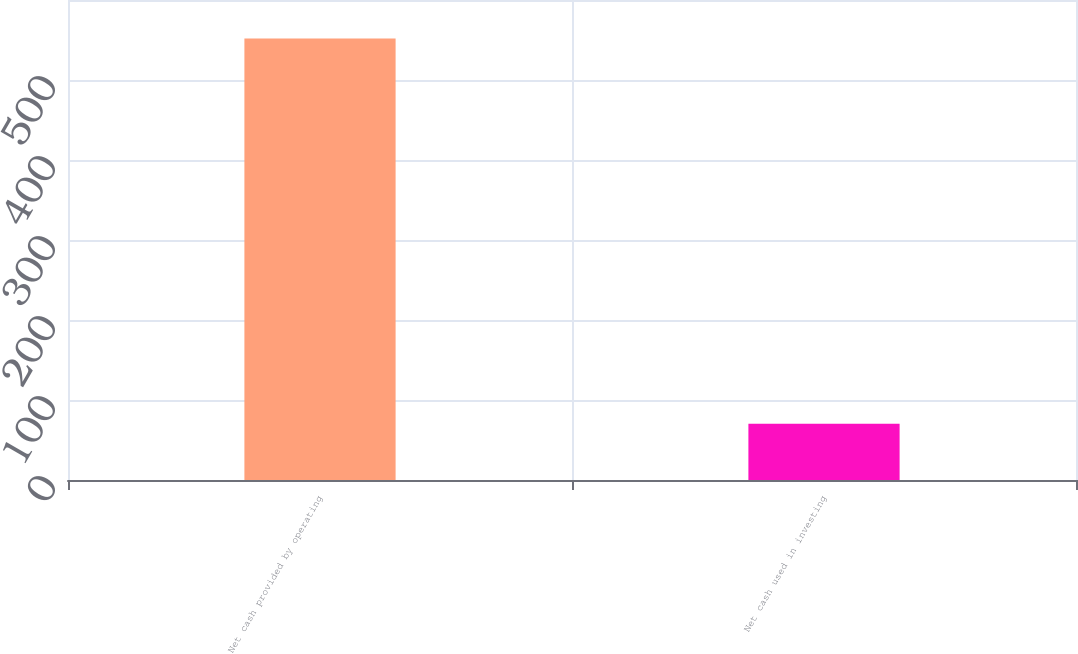<chart> <loc_0><loc_0><loc_500><loc_500><bar_chart><fcel>Net cash provided by operating<fcel>Net cash used in investing<nl><fcel>552<fcel>70.3<nl></chart> 